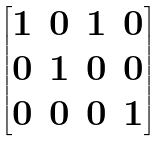Convert formula to latex. <formula><loc_0><loc_0><loc_500><loc_500>\begin{bmatrix} 1 & 0 & 1 & 0 \\ 0 & 1 & 0 & 0 \\ 0 & 0 & 0 & 1 \end{bmatrix}</formula> 